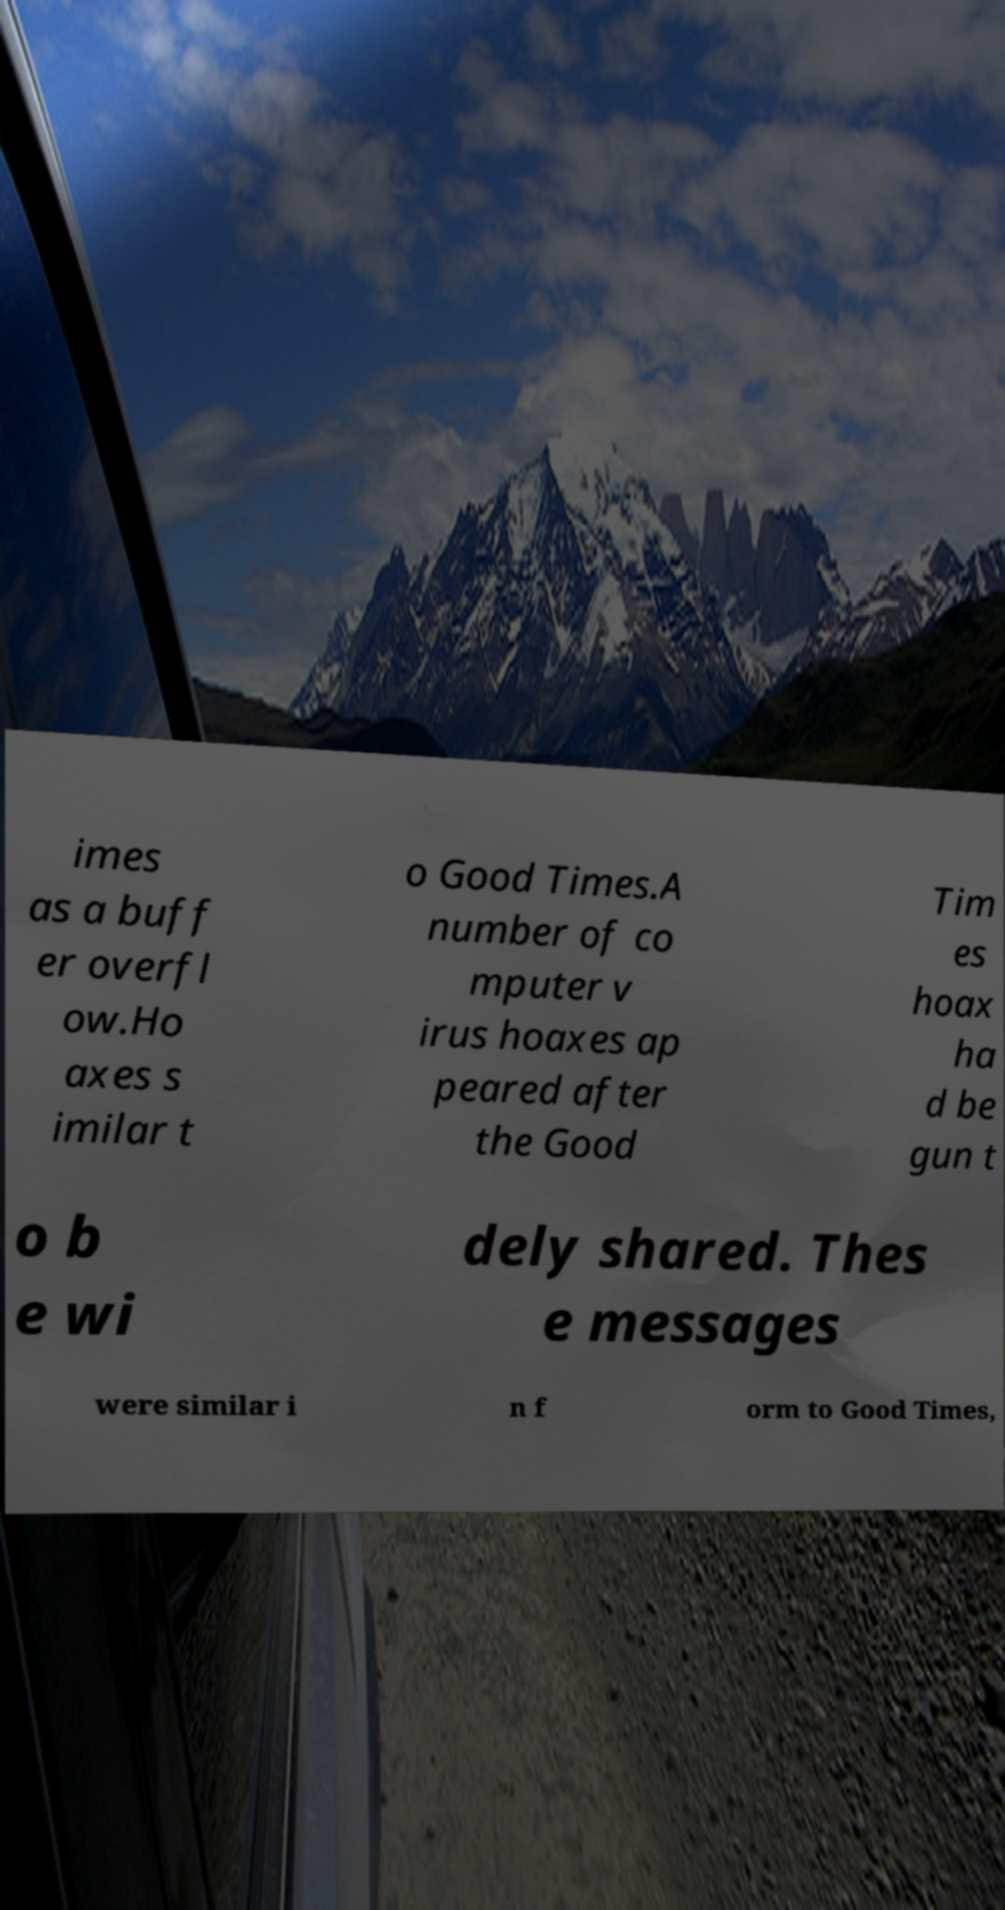Can you read and provide the text displayed in the image?This photo seems to have some interesting text. Can you extract and type it out for me? imes as a buff er overfl ow.Ho axes s imilar t o Good Times.A number of co mputer v irus hoaxes ap peared after the Good Tim es hoax ha d be gun t o b e wi dely shared. Thes e messages were similar i n f orm to Good Times, 